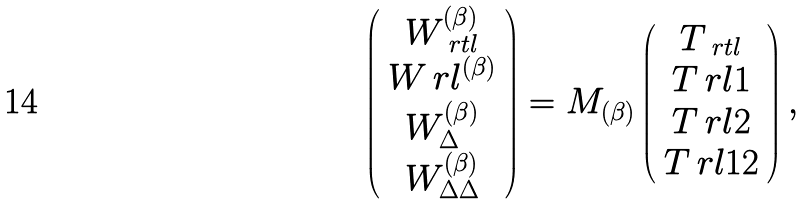Convert formula to latex. <formula><loc_0><loc_0><loc_500><loc_500>\left ( \begin{array} { c } W _ { \ r t l } ^ { ( \beta ) } \\ W _ { \ } r l ^ { ( \beta ) } \\ W _ { \Delta } ^ { ( \beta ) } \\ W _ { \Delta \Delta } ^ { ( \beta ) } \end{array} \right ) = M _ { ( \beta ) } \left ( \begin{array} { c } T _ { \ r t l } \\ T _ { \ } r l 1 \\ T _ { \ } r l 2 \\ T _ { \ } r l 1 2 \end{array} \right ) ,</formula> 